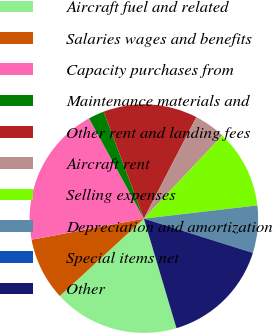Convert chart. <chart><loc_0><loc_0><loc_500><loc_500><pie_chart><fcel>Aircraft fuel and related<fcel>Salaries wages and benefits<fcel>Capacity purchases from<fcel>Maintenance materials and<fcel>Other rent and landing fees<fcel>Aircraft rent<fcel>Selling expenses<fcel>Depreciation and amortization<fcel>Special items net<fcel>Other<nl><fcel>17.76%<fcel>8.89%<fcel>19.98%<fcel>2.24%<fcel>13.33%<fcel>4.45%<fcel>11.11%<fcel>6.67%<fcel>0.02%<fcel>15.55%<nl></chart> 